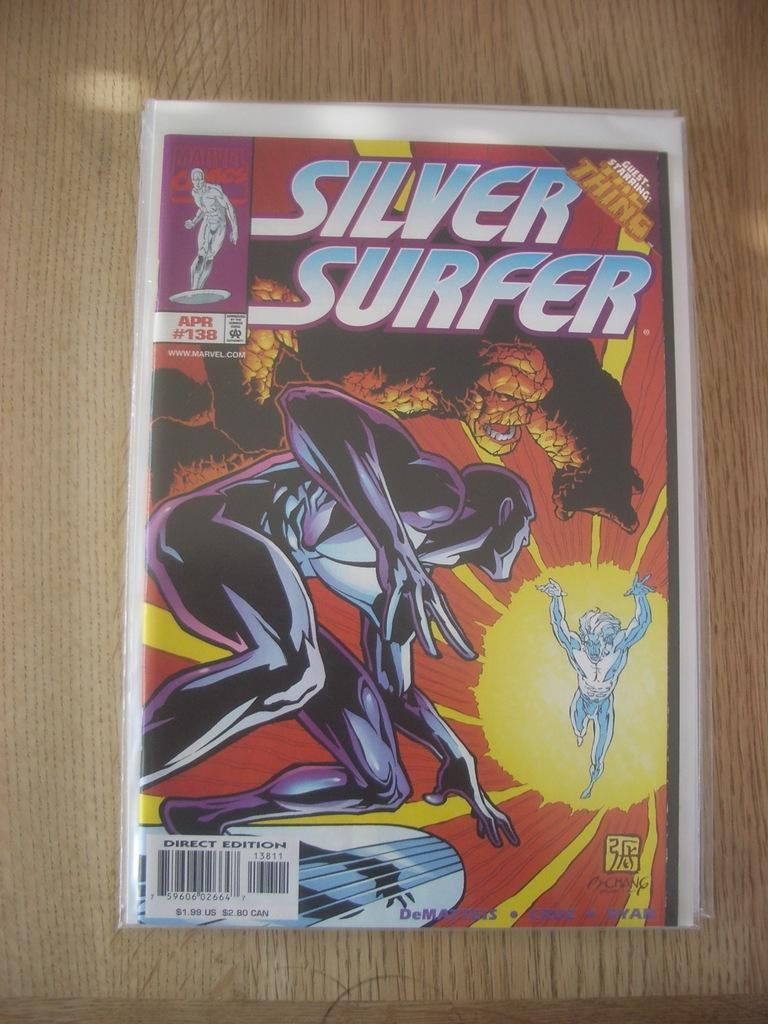<image>
Present a compact description of the photo's key features. an issue of the silver surfer april #138 